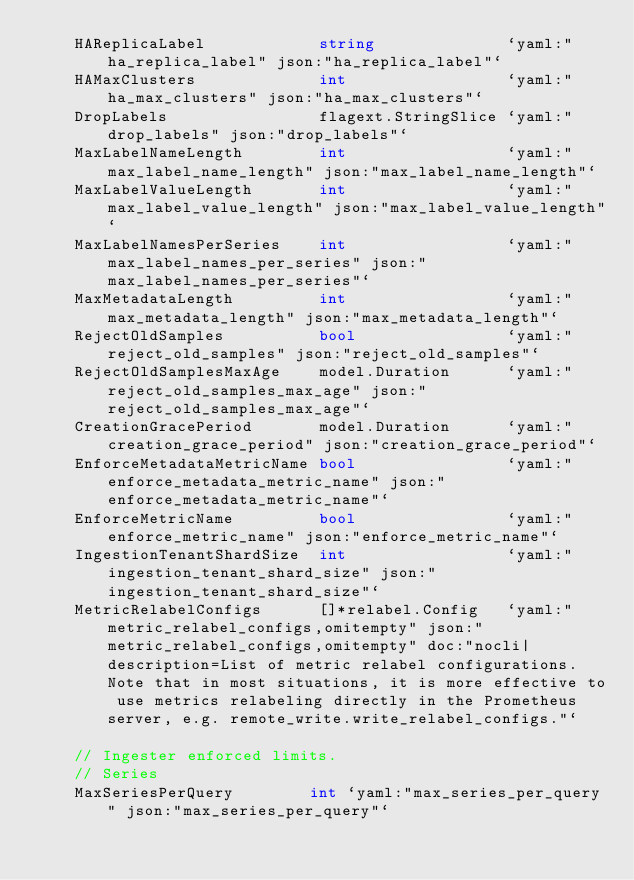Convert code to text. <code><loc_0><loc_0><loc_500><loc_500><_Go_>	HAReplicaLabel            string              `yaml:"ha_replica_label" json:"ha_replica_label"`
	HAMaxClusters             int                 `yaml:"ha_max_clusters" json:"ha_max_clusters"`
	DropLabels                flagext.StringSlice `yaml:"drop_labels" json:"drop_labels"`
	MaxLabelNameLength        int                 `yaml:"max_label_name_length" json:"max_label_name_length"`
	MaxLabelValueLength       int                 `yaml:"max_label_value_length" json:"max_label_value_length"`
	MaxLabelNamesPerSeries    int                 `yaml:"max_label_names_per_series" json:"max_label_names_per_series"`
	MaxMetadataLength         int                 `yaml:"max_metadata_length" json:"max_metadata_length"`
	RejectOldSamples          bool                `yaml:"reject_old_samples" json:"reject_old_samples"`
	RejectOldSamplesMaxAge    model.Duration      `yaml:"reject_old_samples_max_age" json:"reject_old_samples_max_age"`
	CreationGracePeriod       model.Duration      `yaml:"creation_grace_period" json:"creation_grace_period"`
	EnforceMetadataMetricName bool                `yaml:"enforce_metadata_metric_name" json:"enforce_metadata_metric_name"`
	EnforceMetricName         bool                `yaml:"enforce_metric_name" json:"enforce_metric_name"`
	IngestionTenantShardSize  int                 `yaml:"ingestion_tenant_shard_size" json:"ingestion_tenant_shard_size"`
	MetricRelabelConfigs      []*relabel.Config   `yaml:"metric_relabel_configs,omitempty" json:"metric_relabel_configs,omitempty" doc:"nocli|description=List of metric relabel configurations. Note that in most situations, it is more effective to use metrics relabeling directly in the Prometheus server, e.g. remote_write.write_relabel_configs."`

	// Ingester enforced limits.
	// Series
	MaxSeriesPerQuery        int `yaml:"max_series_per_query" json:"max_series_per_query"`</code> 